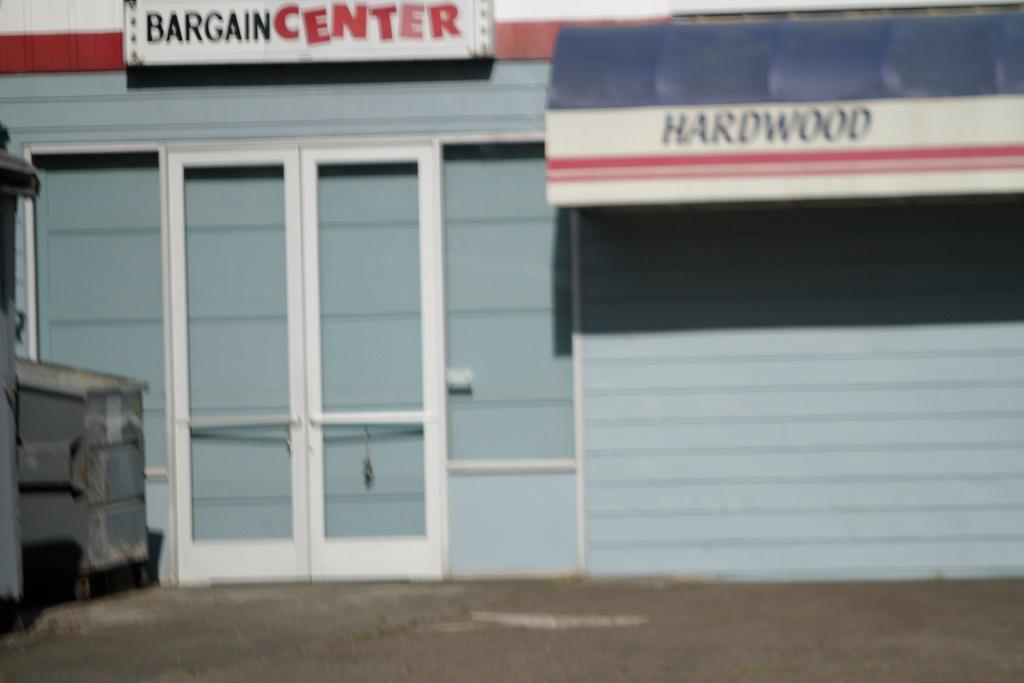Describe this image in one or two sentences. In this image there is a building, a board and a banner with some text attached to the building, there is a door and few objects near the door. 